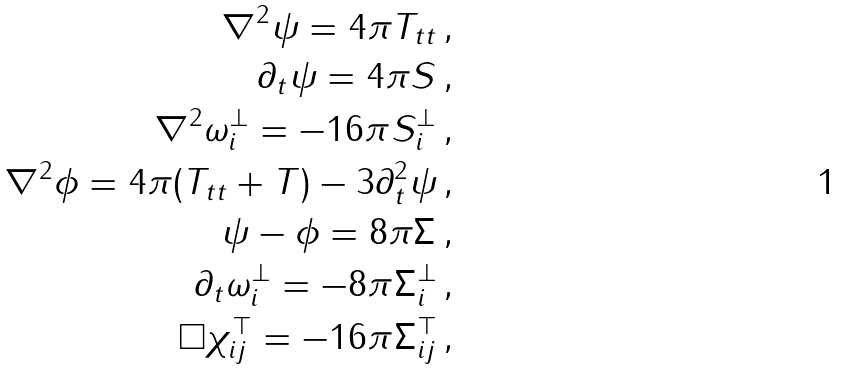<formula> <loc_0><loc_0><loc_500><loc_500>\nabla ^ { 2 } \psi = 4 \pi T _ { t t } \, , \\ \partial _ { t } \psi = 4 \pi S ^ { \| } \, , \\ \nabla ^ { 2 } \omega _ { i } ^ { \bot } = - 1 6 \pi S ^ { \bot } _ { i } \, , \\ \nabla ^ { 2 } \phi = 4 \pi ( T _ { t t } + T ) - 3 \partial ^ { 2 } _ { t } \psi \, , \\ \psi - \phi = 8 \pi \Sigma ^ { \| } \, , \\ \partial _ { t } \omega ^ { \bot } _ { i } = - 8 \pi \Sigma _ { i } ^ { \bot } \, , \\ \Box \chi ^ { \top } _ { i j } = - 1 6 \pi \Sigma ^ { \top } _ { i j } \, ,</formula> 